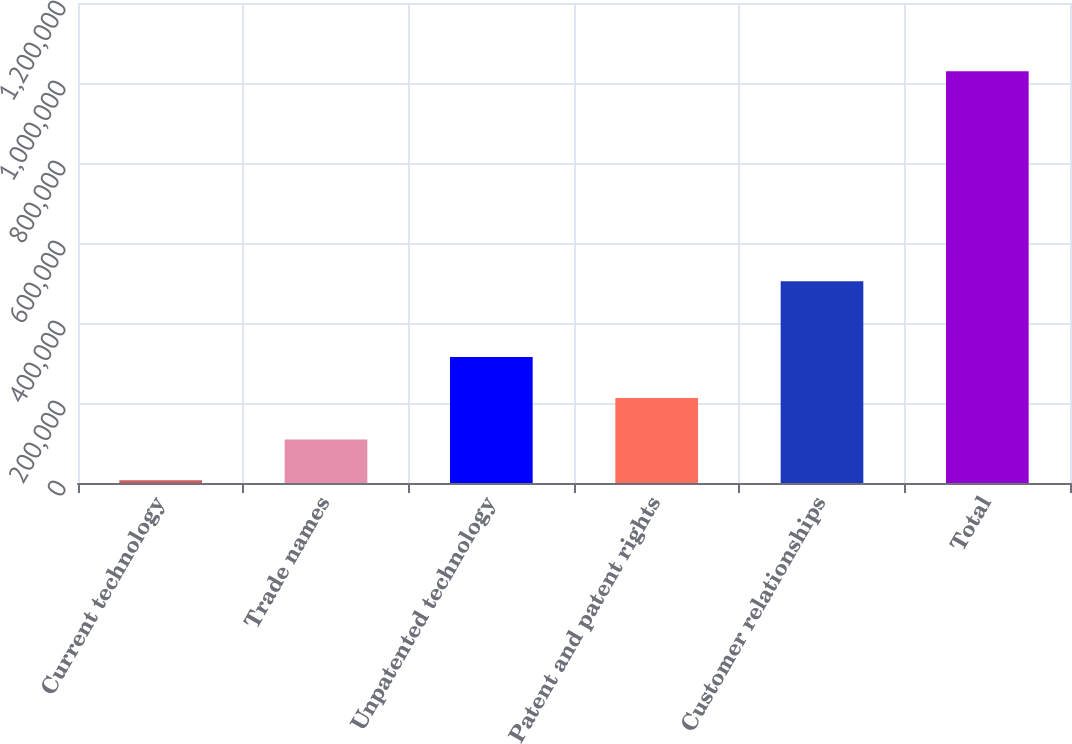Convert chart to OTSL. <chart><loc_0><loc_0><loc_500><loc_500><bar_chart><fcel>Current technology<fcel>Trade names<fcel>Unpatented technology<fcel>Patent and patent rights<fcel>Customer relationships<fcel>Total<nl><fcel>6702<fcel>108961<fcel>314996<fcel>212737<fcel>504410<fcel>1.02929e+06<nl></chart> 